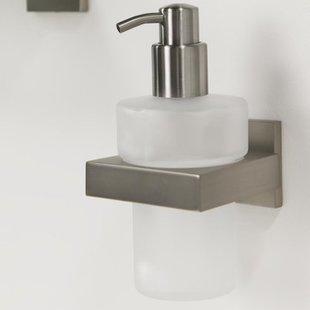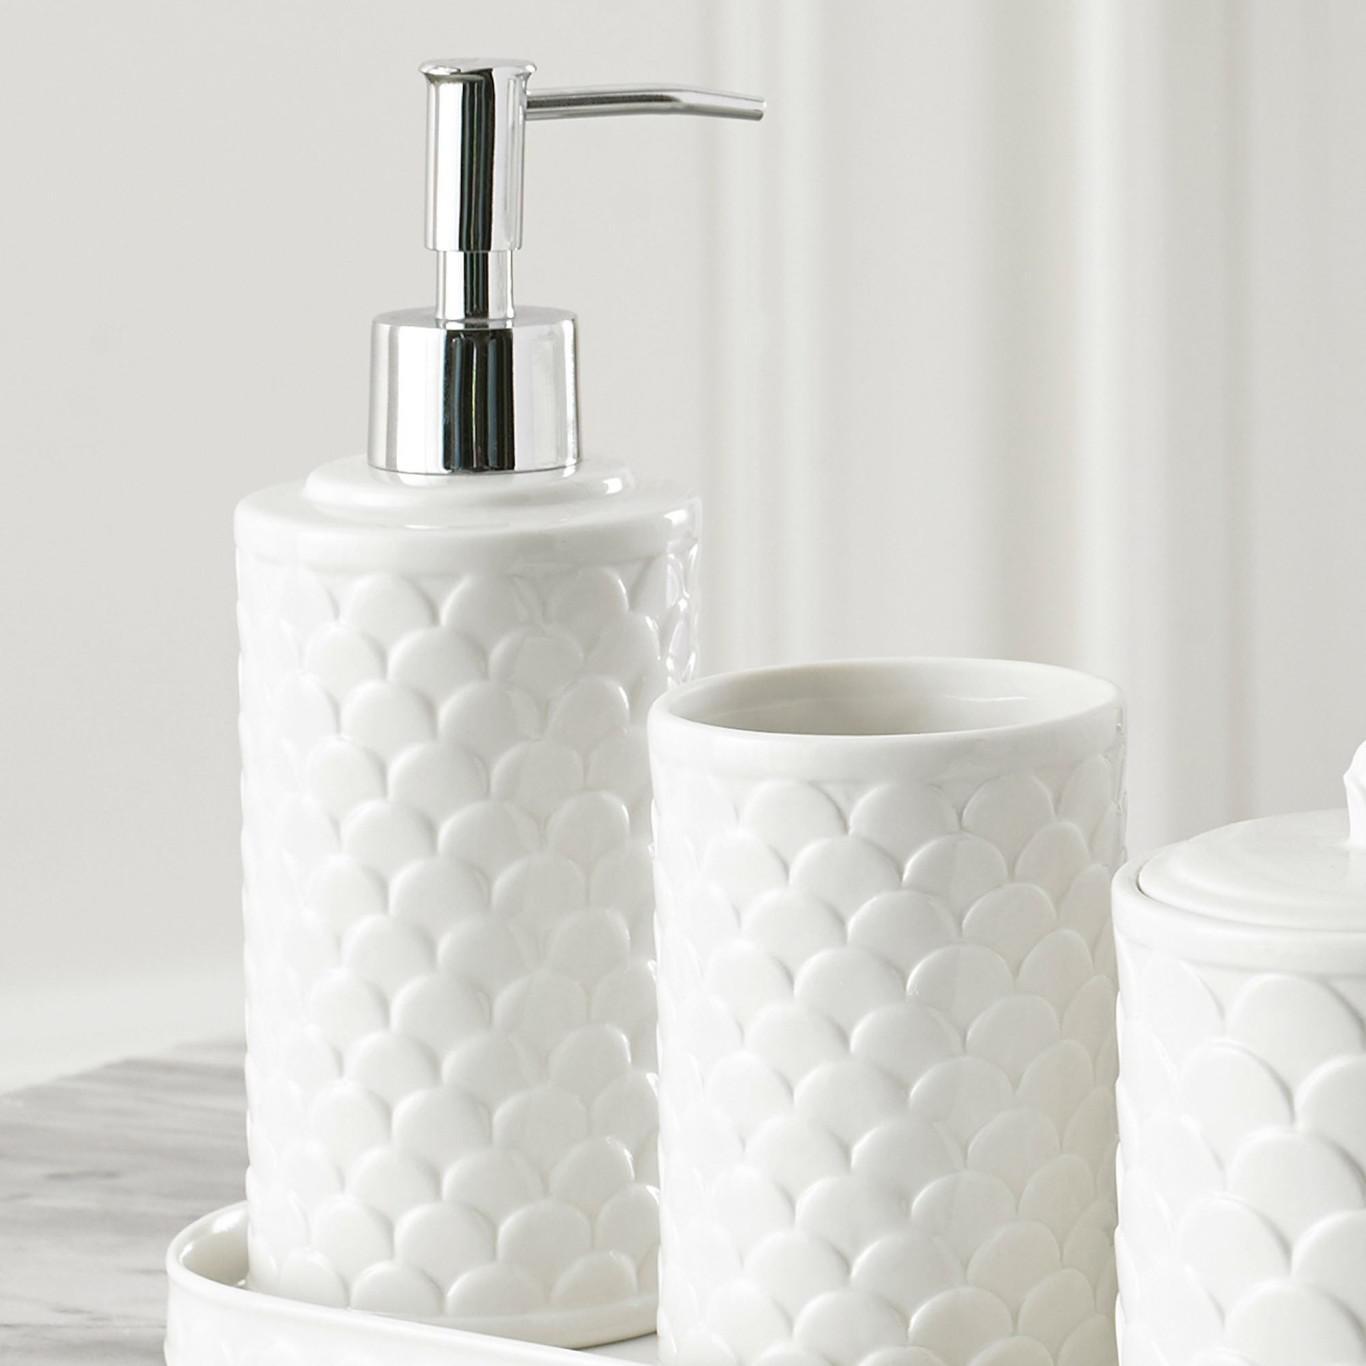The first image is the image on the left, the second image is the image on the right. Given the left and right images, does the statement "The left and right image contains the same number of soap dispenser that sit on the sink." hold true? Answer yes or no. No. The first image is the image on the left, the second image is the image on the right. Analyze the images presented: Is the assertion "There is a clear dispenser with white lotion in it." valid? Answer yes or no. No. 